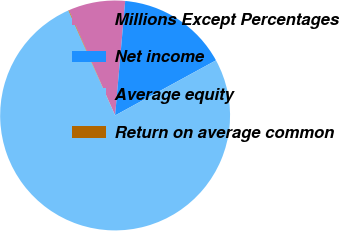Convert chart to OTSL. <chart><loc_0><loc_0><loc_500><loc_500><pie_chart><fcel>Millions Except Percentages<fcel>Net income<fcel>Average equity<fcel>Return on average common<nl><fcel>7.98%<fcel>15.64%<fcel>76.29%<fcel>0.08%<nl></chart> 